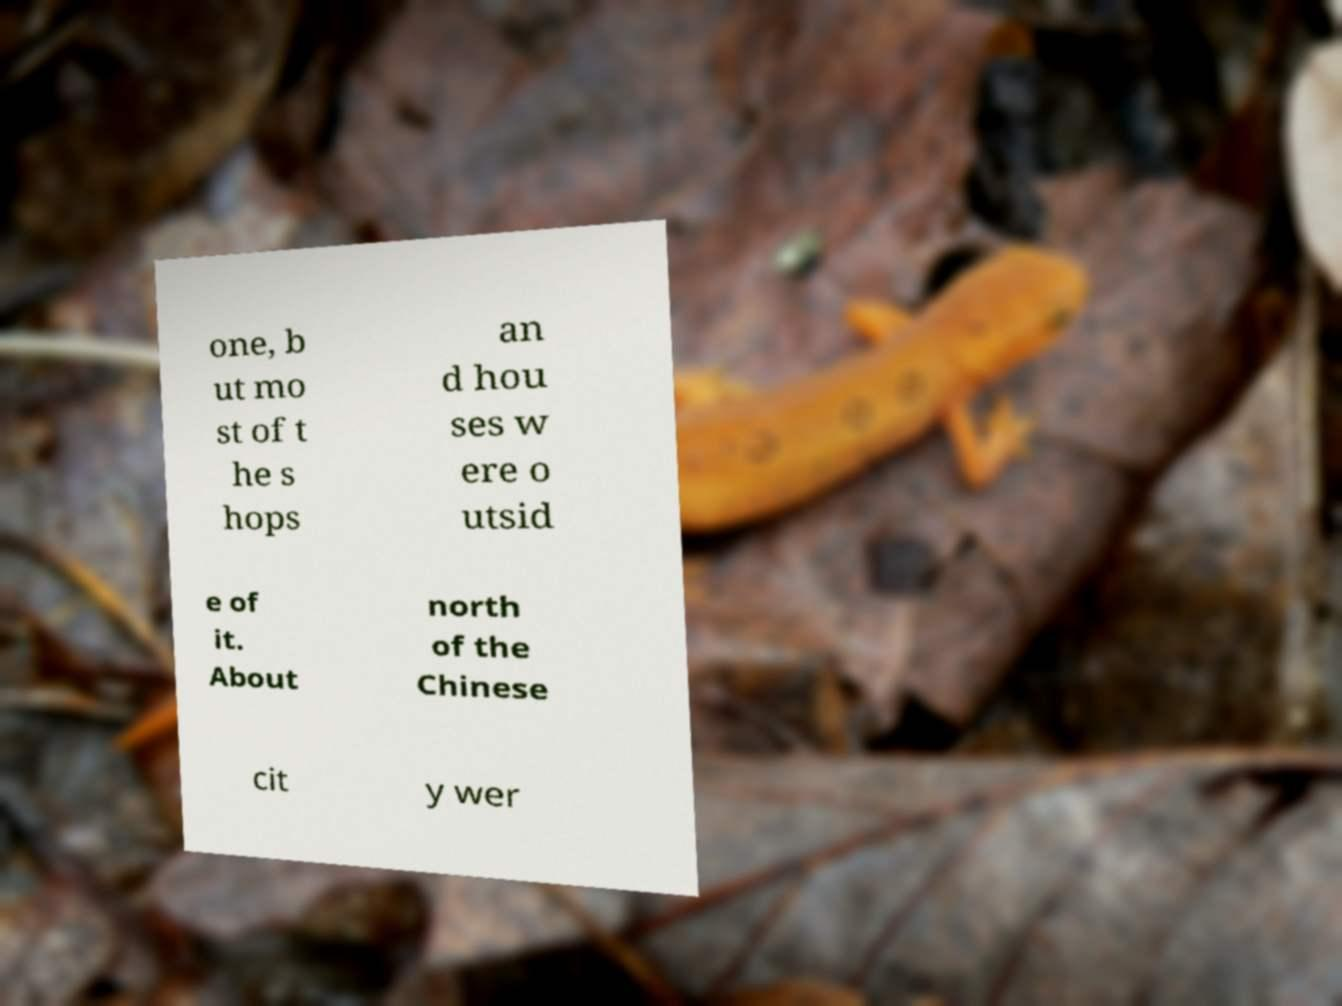Could you assist in decoding the text presented in this image and type it out clearly? one, b ut mo st of t he s hops an d hou ses w ere o utsid e of it. About north of the Chinese cit y wer 